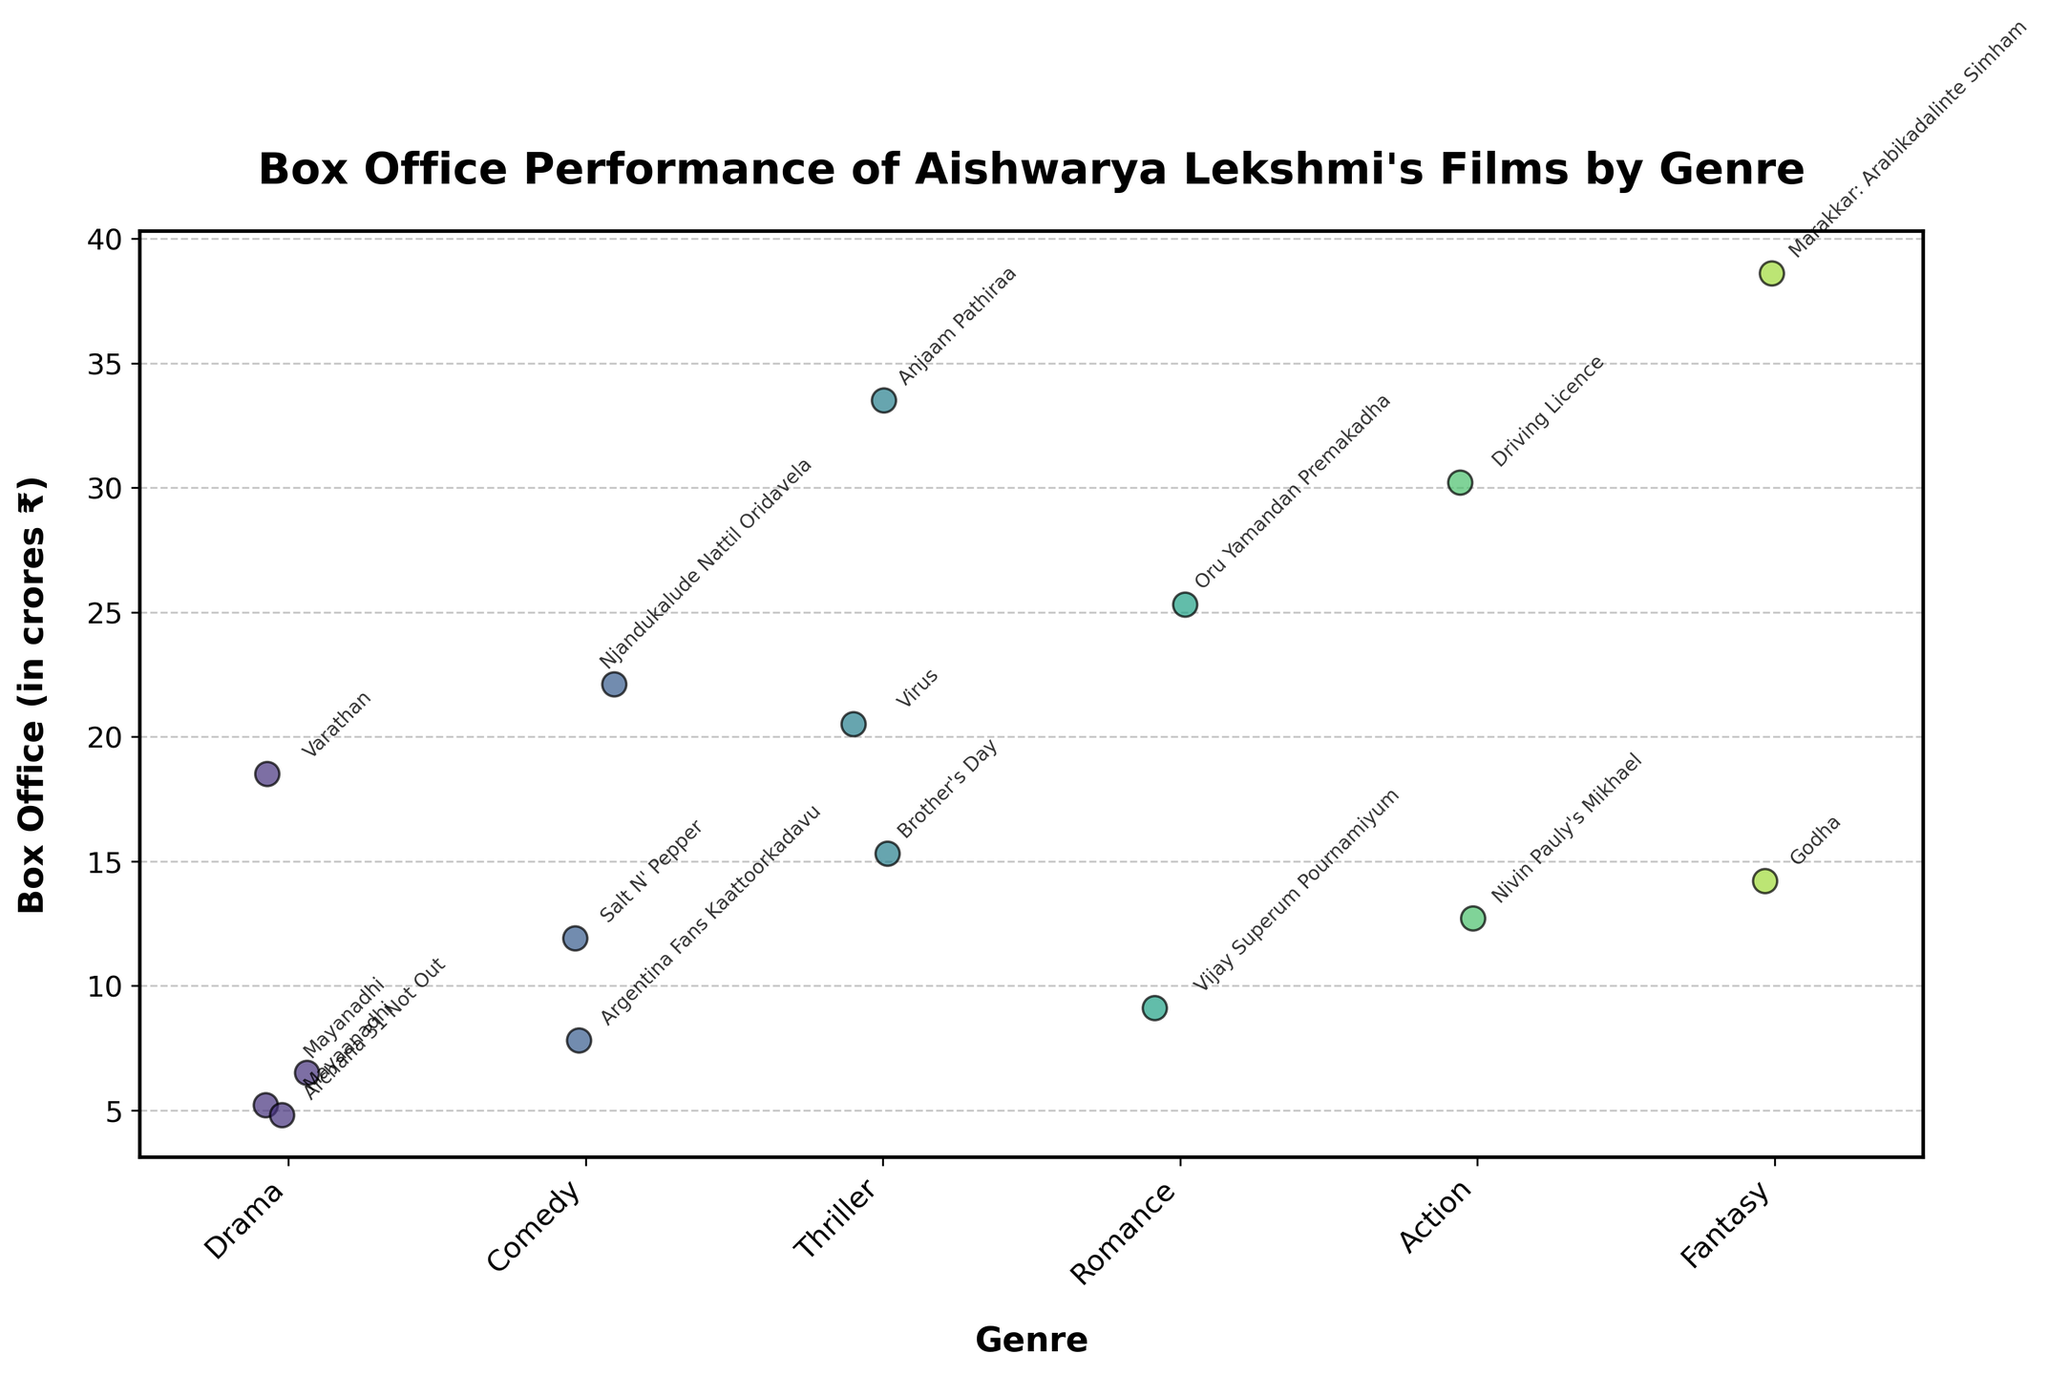What is the title of the strip plot? The title is displayed at the top of the plot, which says "Box Office Performance of Aishwarya Lekshmi's Films by Genre".
Answer: Box Office Performance of Aishwarya Lekshmi's Films by Genre What is the highest box office performance among all genres? By looking at the y-axis values, the highest box office performance shown reaches around 38.6 crores ₹ in the Fantasy genre for the movie Marakkar: Arabikadalinte Simham.
Answer: 38.6 crores ₹ Which genre has the most variability in box office performance? The genre with the most spread of points along the y-axis indicates the most variability. Drama has movies ranging from around 4.8 to 18.5 crores ₹, showing the most variation.
Answer: Drama Which movie in the Thriller genre has the highest box office performance? Within the Thriller genre category, the highest point on the y-axis reaches around 33.5 crores ₹, corresponding to the movie Anjaam Pathiraa.
Answer: Anjaam Pathiraa What is the average box office performance of films in the Comedy genre? There are four movies in the Comedy genre with box office performances of 7.8, 22.1, 11.9, and 11.9 crores ₹. Adding these up: 7.8 + 22.1 + 11.9 + 11.9 = 53.7. Dividing by the number of films (4) gives an average of 13.425 crores ₹.
Answer: 13.425 crores ₹ Which genre contains the lowest box office performance, and which movie does it correspond to? The lowest point on the y-axis corresponds to the Drama genre, with the movie Archana 31 Not Out having a box office performance of 4.8 crores ₹.
Answer: Drama, Archana 31 Not Out How does the box office performance of 'Brother's Day' compare to 'Virus'? The point for 'Brother's Day' in the Thriller genre is at 15.3 crores ₹, while 'Virus' is higher at 20.5 crores ₹.
Answer: Virus is higher than Brother's Day What is the difference in box office performance between the highest-earning movie in the Romance genre and the lowest-earning one? In the Romance genre, Oru Yamandan Premakadha has the highest box office at 25.3 crores ₹, and Vijay Superum Pournamiyum has the lowest at 9.1 crores ₹. The difference is 25.3 - 9.1 = 16.2 crores ₹.
Answer: 16.2 crores ₹ In which genre did Aishwarya Lekshmi achieve box office performance of 14.2 crores ₹, and what is the movie? The point at around 14.2 crores ₹ lies within the Fantasy genre, corresponding to the movie Godha.
Answer: Fantasy, Godha Comparing 'Nivin Pauly's Mikhael' in Action and 'Mayaanadhi' in Drama, which has higher box office performance and by how much? 'Nivin Pauly's Mikhael' is at 12.7 crores ₹ in Action, while 'Mayaanadhi' in Drama is at 5.2 crores ₹. The difference is 12.7 - 5.2 = 7.5 crores ₹.
Answer: Mikhael is higher by 7.5 crores ₹ 